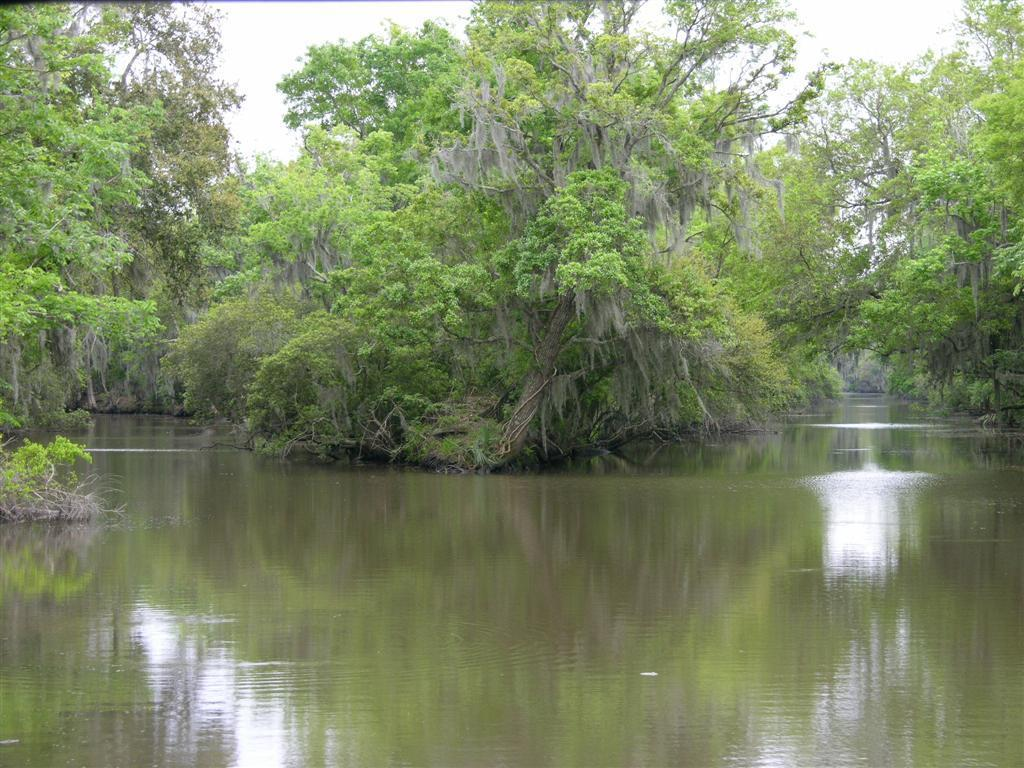What is visible in the foreground of the image? There is water in the foreground of the image. What can be seen in the background of the image? There are trees and water visible in the background of the image. What is the condition of the sky in the image? The sky is cloudy in the image. What type of prose is being recited by the trees in the background of the image? There is no indication in the image that the trees are reciting any prose, as trees do not have the ability to speak or recite literature. 